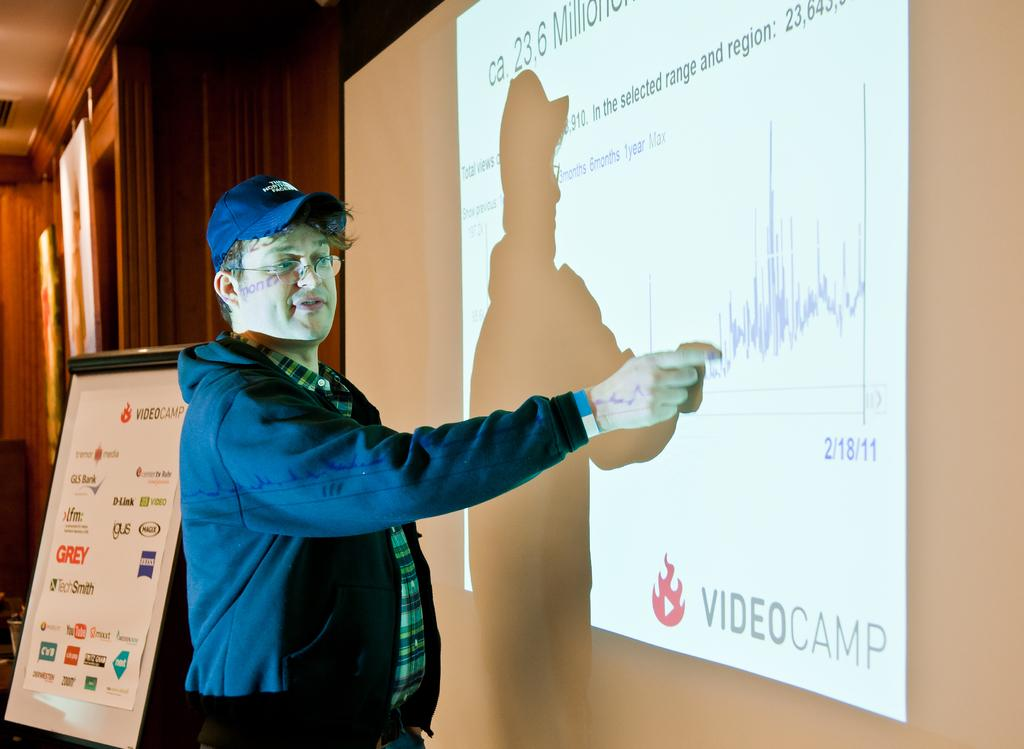Who is present in the image? There is a man in the image. What is the man wearing on his head? The man is wearing a cap. What type of eyewear is the man wearing? The man is wearing spectacles. What is the man standing in front of? The man is standing in front of a projector screen. What can be seen beside the man? There is a hoarding beside the man. What type of hydrant is visible in the image? There is no hydrant present in the image. Is the man holding an umbrella in the image? No, the man is not holding an umbrella in the image. 